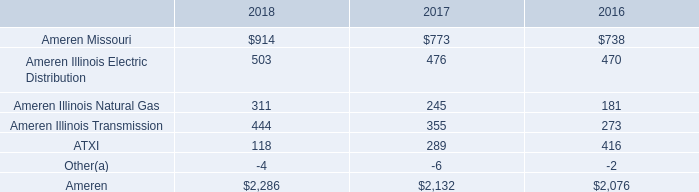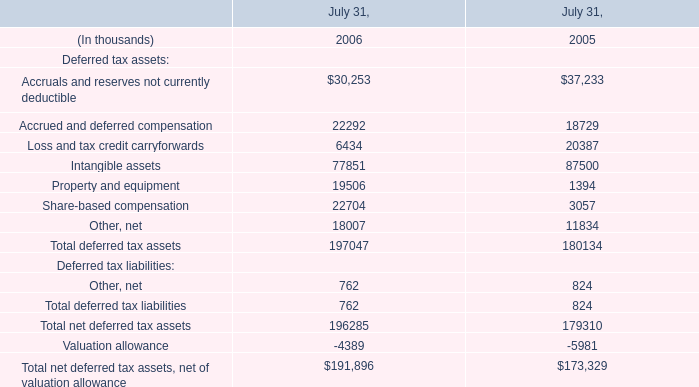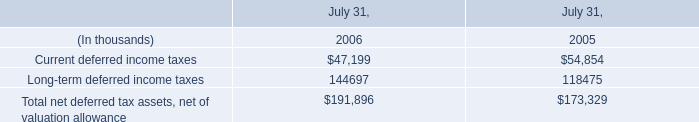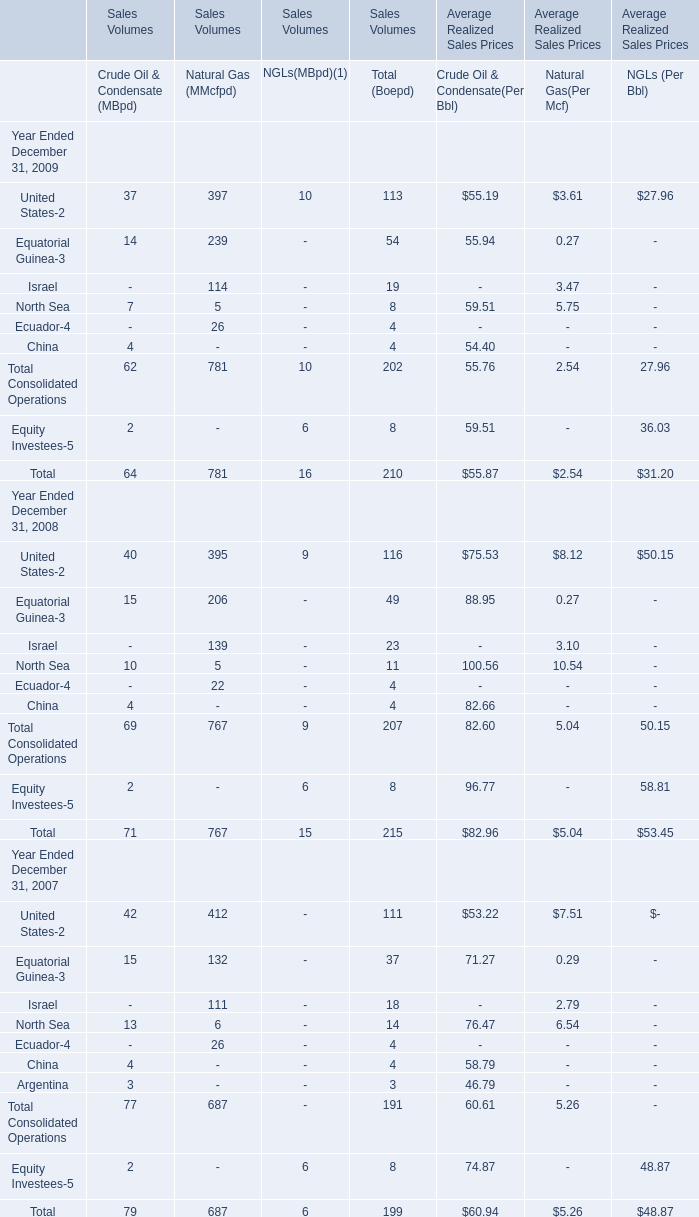What's the total amount of NGLs(MBpd)(1) in the years where Equatorial Guinea-3 greater than 40?? 
Computations: (16 + 15)
Answer: 31.0. 